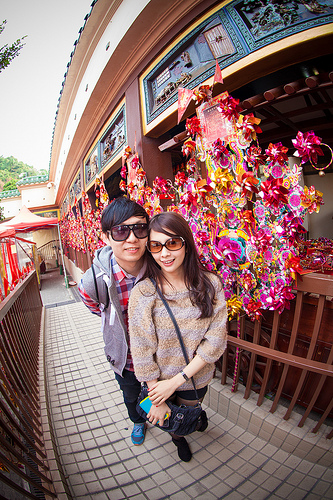<image>
Is there a boy to the left of the girl? Yes. From this viewpoint, the boy is positioned to the left side relative to the girl. 